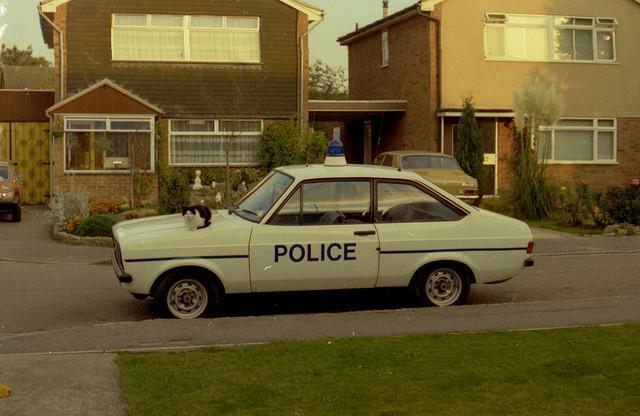How many cats are on the car?
Give a very brief answer. 1. How many doors does the car have?
Give a very brief answer. 2. How many cars are there?
Give a very brief answer. 2. 